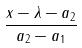<formula> <loc_0><loc_0><loc_500><loc_500>\frac { x - \lambda - a _ { 2 } } { a _ { 2 } - a _ { 1 } }</formula> 